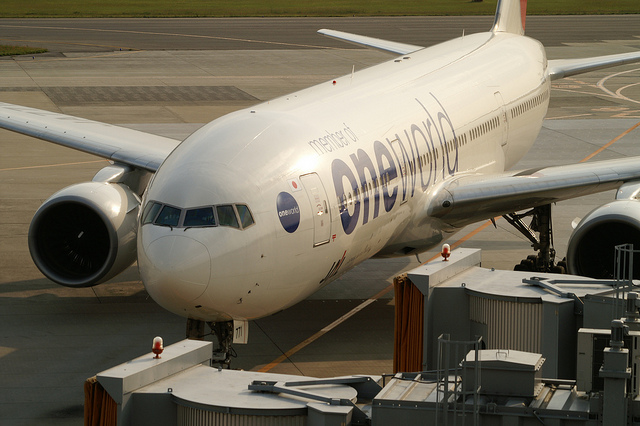<image>What is the name of the airline? I am not sure what the name of the airline is. But it might be 'one world'. What is the name of the airline? I don't know the name of the airline. It can be 'one world'. 